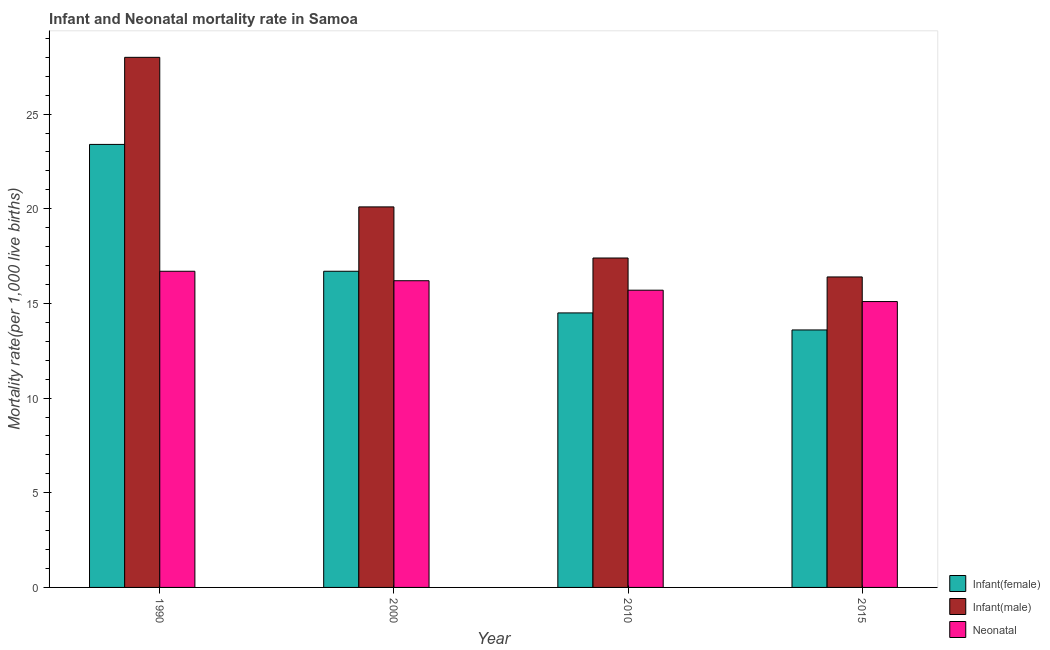How many groups of bars are there?
Give a very brief answer. 4. Are the number of bars on each tick of the X-axis equal?
Ensure brevity in your answer.  Yes. How many bars are there on the 4th tick from the right?
Provide a short and direct response. 3. In how many cases, is the number of bars for a given year not equal to the number of legend labels?
Offer a very short reply. 0. What is the infant mortality rate(male) in 2010?
Make the answer very short. 17.4. Across all years, what is the maximum infant mortality rate(female)?
Your answer should be very brief. 23.4. Across all years, what is the minimum infant mortality rate(male)?
Provide a short and direct response. 16.4. In which year was the infant mortality rate(female) minimum?
Your answer should be very brief. 2015. What is the total neonatal mortality rate in the graph?
Provide a short and direct response. 63.7. What is the difference between the neonatal mortality rate in 2015 and the infant mortality rate(female) in 2010?
Your answer should be very brief. -0.6. What is the average infant mortality rate(female) per year?
Provide a short and direct response. 17.05. In the year 2010, what is the difference between the infant mortality rate(male) and neonatal mortality rate?
Your answer should be compact. 0. What is the ratio of the infant mortality rate(female) in 2010 to that in 2015?
Give a very brief answer. 1.07. What is the difference between the highest and the lowest infant mortality rate(male)?
Your answer should be very brief. 11.6. In how many years, is the infant mortality rate(female) greater than the average infant mortality rate(female) taken over all years?
Make the answer very short. 1. Is the sum of the infant mortality rate(male) in 1990 and 2010 greater than the maximum infant mortality rate(female) across all years?
Provide a short and direct response. Yes. What does the 1st bar from the left in 2015 represents?
Keep it short and to the point. Infant(female). What does the 3rd bar from the right in 2015 represents?
Provide a succinct answer. Infant(female). What is the difference between two consecutive major ticks on the Y-axis?
Your response must be concise. 5. Are the values on the major ticks of Y-axis written in scientific E-notation?
Offer a terse response. No. Does the graph contain any zero values?
Your answer should be very brief. No. What is the title of the graph?
Offer a very short reply. Infant and Neonatal mortality rate in Samoa. Does "Ireland" appear as one of the legend labels in the graph?
Keep it short and to the point. No. What is the label or title of the X-axis?
Give a very brief answer. Year. What is the label or title of the Y-axis?
Your answer should be compact. Mortality rate(per 1,0 live births). What is the Mortality rate(per 1,000 live births) in Infant(female) in 1990?
Provide a succinct answer. 23.4. What is the Mortality rate(per 1,000 live births) of Infant(male) in 1990?
Give a very brief answer. 28. What is the Mortality rate(per 1,000 live births) of Infant(male) in 2000?
Ensure brevity in your answer.  20.1. What is the Mortality rate(per 1,000 live births) in Infant(female) in 2010?
Provide a short and direct response. 14.5. What is the Mortality rate(per 1,000 live births) of Infant(male) in 2010?
Ensure brevity in your answer.  17.4. What is the Mortality rate(per 1,000 live births) in Infant(female) in 2015?
Your response must be concise. 13.6. What is the Mortality rate(per 1,000 live births) in Infant(male) in 2015?
Your answer should be compact. 16.4. Across all years, what is the maximum Mortality rate(per 1,000 live births) of Infant(female)?
Your answer should be compact. 23.4. Across all years, what is the maximum Mortality rate(per 1,000 live births) of Neonatal ?
Your response must be concise. 16.7. Across all years, what is the minimum Mortality rate(per 1,000 live births) of Infant(female)?
Keep it short and to the point. 13.6. Across all years, what is the minimum Mortality rate(per 1,000 live births) in Neonatal ?
Give a very brief answer. 15.1. What is the total Mortality rate(per 1,000 live births) in Infant(female) in the graph?
Ensure brevity in your answer.  68.2. What is the total Mortality rate(per 1,000 live births) in Infant(male) in the graph?
Offer a terse response. 81.9. What is the total Mortality rate(per 1,000 live births) of Neonatal  in the graph?
Your response must be concise. 63.7. What is the difference between the Mortality rate(per 1,000 live births) of Neonatal  in 1990 and that in 2000?
Make the answer very short. 0.5. What is the difference between the Mortality rate(per 1,000 live births) in Infant(female) in 1990 and that in 2010?
Keep it short and to the point. 8.9. What is the difference between the Mortality rate(per 1,000 live births) of Infant(male) in 1990 and that in 2010?
Your response must be concise. 10.6. What is the difference between the Mortality rate(per 1,000 live births) of Infant(female) in 1990 and that in 2015?
Provide a short and direct response. 9.8. What is the difference between the Mortality rate(per 1,000 live births) of Infant(male) in 1990 and that in 2015?
Give a very brief answer. 11.6. What is the difference between the Mortality rate(per 1,000 live births) of Neonatal  in 1990 and that in 2015?
Provide a short and direct response. 1.6. What is the difference between the Mortality rate(per 1,000 live births) in Infant(male) in 2000 and that in 2010?
Ensure brevity in your answer.  2.7. What is the difference between the Mortality rate(per 1,000 live births) in Infant(male) in 2000 and that in 2015?
Provide a succinct answer. 3.7. What is the difference between the Mortality rate(per 1,000 live births) in Neonatal  in 2000 and that in 2015?
Give a very brief answer. 1.1. What is the difference between the Mortality rate(per 1,000 live births) in Infant(female) in 1990 and the Mortality rate(per 1,000 live births) in Infant(male) in 2010?
Keep it short and to the point. 6. What is the difference between the Mortality rate(per 1,000 live births) of Infant(female) in 1990 and the Mortality rate(per 1,000 live births) of Neonatal  in 2010?
Keep it short and to the point. 7.7. What is the difference between the Mortality rate(per 1,000 live births) in Infant(female) in 1990 and the Mortality rate(per 1,000 live births) in Infant(male) in 2015?
Provide a succinct answer. 7. What is the difference between the Mortality rate(per 1,000 live births) of Infant(female) in 2000 and the Mortality rate(per 1,000 live births) of Neonatal  in 2010?
Offer a very short reply. 1. What is the difference between the Mortality rate(per 1,000 live births) of Infant(male) in 2000 and the Mortality rate(per 1,000 live births) of Neonatal  in 2010?
Your answer should be compact. 4.4. What is the average Mortality rate(per 1,000 live births) in Infant(female) per year?
Your answer should be compact. 17.05. What is the average Mortality rate(per 1,000 live births) of Infant(male) per year?
Your answer should be compact. 20.48. What is the average Mortality rate(per 1,000 live births) in Neonatal  per year?
Ensure brevity in your answer.  15.93. In the year 1990, what is the difference between the Mortality rate(per 1,000 live births) of Infant(female) and Mortality rate(per 1,000 live births) of Infant(male)?
Keep it short and to the point. -4.6. In the year 1990, what is the difference between the Mortality rate(per 1,000 live births) of Infant(female) and Mortality rate(per 1,000 live births) of Neonatal ?
Your response must be concise. 6.7. In the year 1990, what is the difference between the Mortality rate(per 1,000 live births) in Infant(male) and Mortality rate(per 1,000 live births) in Neonatal ?
Offer a very short reply. 11.3. In the year 2000, what is the difference between the Mortality rate(per 1,000 live births) of Infant(female) and Mortality rate(per 1,000 live births) of Neonatal ?
Keep it short and to the point. 0.5. In the year 2015, what is the difference between the Mortality rate(per 1,000 live births) of Infant(female) and Mortality rate(per 1,000 live births) of Infant(male)?
Provide a short and direct response. -2.8. What is the ratio of the Mortality rate(per 1,000 live births) in Infant(female) in 1990 to that in 2000?
Keep it short and to the point. 1.4. What is the ratio of the Mortality rate(per 1,000 live births) of Infant(male) in 1990 to that in 2000?
Your response must be concise. 1.39. What is the ratio of the Mortality rate(per 1,000 live births) of Neonatal  in 1990 to that in 2000?
Offer a terse response. 1.03. What is the ratio of the Mortality rate(per 1,000 live births) in Infant(female) in 1990 to that in 2010?
Provide a short and direct response. 1.61. What is the ratio of the Mortality rate(per 1,000 live births) of Infant(male) in 1990 to that in 2010?
Your answer should be compact. 1.61. What is the ratio of the Mortality rate(per 1,000 live births) in Neonatal  in 1990 to that in 2010?
Ensure brevity in your answer.  1.06. What is the ratio of the Mortality rate(per 1,000 live births) of Infant(female) in 1990 to that in 2015?
Offer a terse response. 1.72. What is the ratio of the Mortality rate(per 1,000 live births) of Infant(male) in 1990 to that in 2015?
Your answer should be very brief. 1.71. What is the ratio of the Mortality rate(per 1,000 live births) in Neonatal  in 1990 to that in 2015?
Make the answer very short. 1.11. What is the ratio of the Mortality rate(per 1,000 live births) in Infant(female) in 2000 to that in 2010?
Provide a succinct answer. 1.15. What is the ratio of the Mortality rate(per 1,000 live births) in Infant(male) in 2000 to that in 2010?
Give a very brief answer. 1.16. What is the ratio of the Mortality rate(per 1,000 live births) in Neonatal  in 2000 to that in 2010?
Offer a very short reply. 1.03. What is the ratio of the Mortality rate(per 1,000 live births) in Infant(female) in 2000 to that in 2015?
Your response must be concise. 1.23. What is the ratio of the Mortality rate(per 1,000 live births) of Infant(male) in 2000 to that in 2015?
Make the answer very short. 1.23. What is the ratio of the Mortality rate(per 1,000 live births) of Neonatal  in 2000 to that in 2015?
Your answer should be very brief. 1.07. What is the ratio of the Mortality rate(per 1,000 live births) of Infant(female) in 2010 to that in 2015?
Your response must be concise. 1.07. What is the ratio of the Mortality rate(per 1,000 live births) of Infant(male) in 2010 to that in 2015?
Your response must be concise. 1.06. What is the ratio of the Mortality rate(per 1,000 live births) in Neonatal  in 2010 to that in 2015?
Make the answer very short. 1.04. What is the difference between the highest and the second highest Mortality rate(per 1,000 live births) in Infant(female)?
Your response must be concise. 6.7. What is the difference between the highest and the second highest Mortality rate(per 1,000 live births) of Neonatal ?
Offer a terse response. 0.5. What is the difference between the highest and the lowest Mortality rate(per 1,000 live births) in Neonatal ?
Provide a succinct answer. 1.6. 